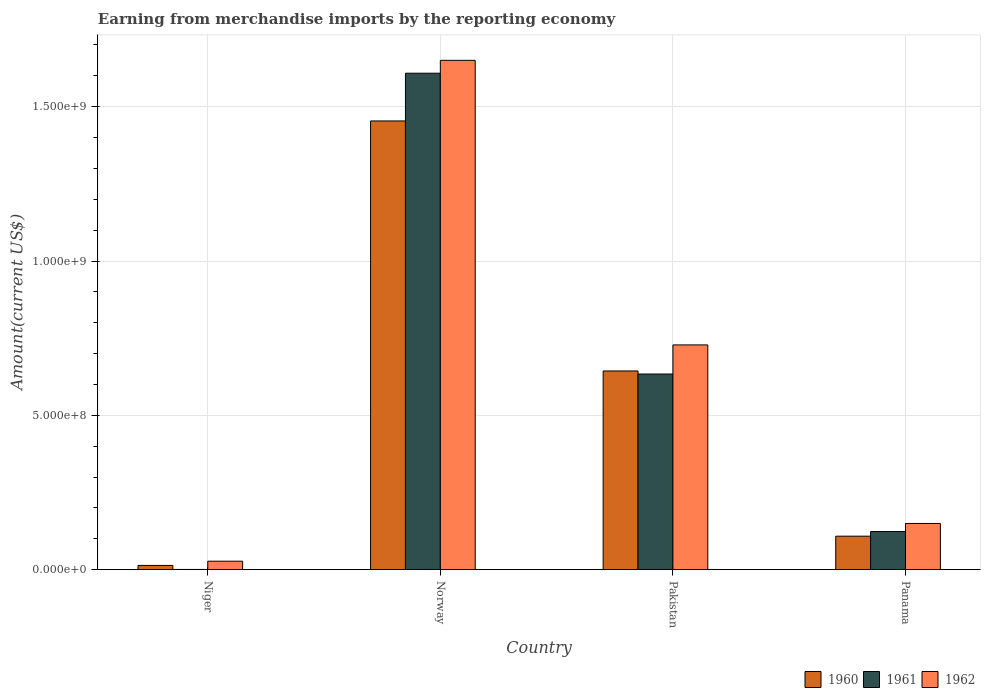How many different coloured bars are there?
Keep it short and to the point. 3. How many bars are there on the 4th tick from the left?
Give a very brief answer. 3. What is the label of the 4th group of bars from the left?
Your response must be concise. Panama. What is the amount earned from merchandise imports in 1962 in Norway?
Your answer should be compact. 1.65e+09. Across all countries, what is the maximum amount earned from merchandise imports in 1960?
Offer a terse response. 1.45e+09. Across all countries, what is the minimum amount earned from merchandise imports in 1960?
Provide a short and direct response. 1.36e+07. In which country was the amount earned from merchandise imports in 1961 maximum?
Your answer should be compact. Norway. In which country was the amount earned from merchandise imports in 1961 minimum?
Offer a very short reply. Niger. What is the total amount earned from merchandise imports in 1962 in the graph?
Your answer should be compact. 2.56e+09. What is the difference between the amount earned from merchandise imports in 1962 in Niger and that in Norway?
Offer a very short reply. -1.62e+09. What is the difference between the amount earned from merchandise imports in 1960 in Norway and the amount earned from merchandise imports in 1961 in Pakistan?
Offer a very short reply. 8.20e+08. What is the average amount earned from merchandise imports in 1961 per country?
Make the answer very short. 5.92e+08. What is the difference between the amount earned from merchandise imports of/in 1962 and amount earned from merchandise imports of/in 1960 in Pakistan?
Your answer should be very brief. 8.44e+07. What is the ratio of the amount earned from merchandise imports in 1961 in Niger to that in Pakistan?
Offer a terse response. 0. Is the amount earned from merchandise imports in 1961 in Norway less than that in Pakistan?
Provide a succinct answer. No. What is the difference between the highest and the second highest amount earned from merchandise imports in 1961?
Make the answer very short. 9.75e+08. What is the difference between the highest and the lowest amount earned from merchandise imports in 1961?
Your response must be concise. 1.61e+09. What does the 1st bar from the left in Norway represents?
Your answer should be compact. 1960. What does the 2nd bar from the right in Pakistan represents?
Provide a succinct answer. 1961. How many bars are there?
Keep it short and to the point. 12. Are all the bars in the graph horizontal?
Offer a terse response. No. How many countries are there in the graph?
Your response must be concise. 4. Are the values on the major ticks of Y-axis written in scientific E-notation?
Your answer should be compact. Yes. Does the graph contain grids?
Ensure brevity in your answer.  Yes. Where does the legend appear in the graph?
Offer a very short reply. Bottom right. How many legend labels are there?
Provide a short and direct response. 3. How are the legend labels stacked?
Your answer should be very brief. Horizontal. What is the title of the graph?
Give a very brief answer. Earning from merchandise imports by the reporting economy. Does "1982" appear as one of the legend labels in the graph?
Ensure brevity in your answer.  No. What is the label or title of the X-axis?
Keep it short and to the point. Country. What is the label or title of the Y-axis?
Make the answer very short. Amount(current US$). What is the Amount(current US$) in 1960 in Niger?
Keep it short and to the point. 1.36e+07. What is the Amount(current US$) of 1961 in Niger?
Give a very brief answer. 6.00e+05. What is the Amount(current US$) in 1962 in Niger?
Your answer should be compact. 2.73e+07. What is the Amount(current US$) in 1960 in Norway?
Keep it short and to the point. 1.45e+09. What is the Amount(current US$) in 1961 in Norway?
Make the answer very short. 1.61e+09. What is the Amount(current US$) in 1962 in Norway?
Give a very brief answer. 1.65e+09. What is the Amount(current US$) of 1960 in Pakistan?
Ensure brevity in your answer.  6.44e+08. What is the Amount(current US$) in 1961 in Pakistan?
Offer a terse response. 6.34e+08. What is the Amount(current US$) in 1962 in Pakistan?
Offer a terse response. 7.28e+08. What is the Amount(current US$) of 1960 in Panama?
Provide a short and direct response. 1.08e+08. What is the Amount(current US$) in 1961 in Panama?
Keep it short and to the point. 1.23e+08. What is the Amount(current US$) of 1962 in Panama?
Ensure brevity in your answer.  1.50e+08. Across all countries, what is the maximum Amount(current US$) in 1960?
Give a very brief answer. 1.45e+09. Across all countries, what is the maximum Amount(current US$) in 1961?
Offer a very short reply. 1.61e+09. Across all countries, what is the maximum Amount(current US$) in 1962?
Make the answer very short. 1.65e+09. Across all countries, what is the minimum Amount(current US$) of 1960?
Your response must be concise. 1.36e+07. Across all countries, what is the minimum Amount(current US$) of 1962?
Your answer should be very brief. 2.73e+07. What is the total Amount(current US$) of 1960 in the graph?
Your answer should be very brief. 2.22e+09. What is the total Amount(current US$) of 1961 in the graph?
Offer a very short reply. 2.37e+09. What is the total Amount(current US$) of 1962 in the graph?
Provide a short and direct response. 2.56e+09. What is the difference between the Amount(current US$) of 1960 in Niger and that in Norway?
Ensure brevity in your answer.  -1.44e+09. What is the difference between the Amount(current US$) of 1961 in Niger and that in Norway?
Offer a very short reply. -1.61e+09. What is the difference between the Amount(current US$) of 1962 in Niger and that in Norway?
Make the answer very short. -1.62e+09. What is the difference between the Amount(current US$) in 1960 in Niger and that in Pakistan?
Ensure brevity in your answer.  -6.30e+08. What is the difference between the Amount(current US$) in 1961 in Niger and that in Pakistan?
Your answer should be very brief. -6.33e+08. What is the difference between the Amount(current US$) of 1962 in Niger and that in Pakistan?
Give a very brief answer. -7.01e+08. What is the difference between the Amount(current US$) of 1960 in Niger and that in Panama?
Offer a terse response. -9.48e+07. What is the difference between the Amount(current US$) in 1961 in Niger and that in Panama?
Your response must be concise. -1.23e+08. What is the difference between the Amount(current US$) in 1962 in Niger and that in Panama?
Provide a short and direct response. -1.22e+08. What is the difference between the Amount(current US$) of 1960 in Norway and that in Pakistan?
Offer a very short reply. 8.10e+08. What is the difference between the Amount(current US$) of 1961 in Norway and that in Pakistan?
Make the answer very short. 9.75e+08. What is the difference between the Amount(current US$) of 1962 in Norway and that in Pakistan?
Keep it short and to the point. 9.22e+08. What is the difference between the Amount(current US$) of 1960 in Norway and that in Panama?
Your answer should be compact. 1.35e+09. What is the difference between the Amount(current US$) of 1961 in Norway and that in Panama?
Provide a short and direct response. 1.49e+09. What is the difference between the Amount(current US$) of 1962 in Norway and that in Panama?
Keep it short and to the point. 1.50e+09. What is the difference between the Amount(current US$) of 1960 in Pakistan and that in Panama?
Your response must be concise. 5.35e+08. What is the difference between the Amount(current US$) in 1961 in Pakistan and that in Panama?
Offer a very short reply. 5.10e+08. What is the difference between the Amount(current US$) in 1962 in Pakistan and that in Panama?
Provide a succinct answer. 5.78e+08. What is the difference between the Amount(current US$) in 1960 in Niger and the Amount(current US$) in 1961 in Norway?
Keep it short and to the point. -1.59e+09. What is the difference between the Amount(current US$) in 1960 in Niger and the Amount(current US$) in 1962 in Norway?
Offer a very short reply. -1.64e+09. What is the difference between the Amount(current US$) in 1961 in Niger and the Amount(current US$) in 1962 in Norway?
Offer a very short reply. -1.65e+09. What is the difference between the Amount(current US$) of 1960 in Niger and the Amount(current US$) of 1961 in Pakistan?
Your answer should be very brief. -6.20e+08. What is the difference between the Amount(current US$) of 1960 in Niger and the Amount(current US$) of 1962 in Pakistan?
Offer a terse response. -7.14e+08. What is the difference between the Amount(current US$) of 1961 in Niger and the Amount(current US$) of 1962 in Pakistan?
Keep it short and to the point. -7.28e+08. What is the difference between the Amount(current US$) of 1960 in Niger and the Amount(current US$) of 1961 in Panama?
Offer a very short reply. -1.10e+08. What is the difference between the Amount(current US$) in 1960 in Niger and the Amount(current US$) in 1962 in Panama?
Keep it short and to the point. -1.36e+08. What is the difference between the Amount(current US$) of 1961 in Niger and the Amount(current US$) of 1962 in Panama?
Your answer should be very brief. -1.49e+08. What is the difference between the Amount(current US$) of 1960 in Norway and the Amount(current US$) of 1961 in Pakistan?
Provide a succinct answer. 8.20e+08. What is the difference between the Amount(current US$) of 1960 in Norway and the Amount(current US$) of 1962 in Pakistan?
Provide a short and direct response. 7.26e+08. What is the difference between the Amount(current US$) of 1961 in Norway and the Amount(current US$) of 1962 in Pakistan?
Ensure brevity in your answer.  8.80e+08. What is the difference between the Amount(current US$) in 1960 in Norway and the Amount(current US$) in 1961 in Panama?
Your answer should be very brief. 1.33e+09. What is the difference between the Amount(current US$) of 1960 in Norway and the Amount(current US$) of 1962 in Panama?
Keep it short and to the point. 1.30e+09. What is the difference between the Amount(current US$) in 1961 in Norway and the Amount(current US$) in 1962 in Panama?
Provide a succinct answer. 1.46e+09. What is the difference between the Amount(current US$) of 1960 in Pakistan and the Amount(current US$) of 1961 in Panama?
Provide a short and direct response. 5.20e+08. What is the difference between the Amount(current US$) in 1960 in Pakistan and the Amount(current US$) in 1962 in Panama?
Make the answer very short. 4.94e+08. What is the difference between the Amount(current US$) of 1961 in Pakistan and the Amount(current US$) of 1962 in Panama?
Offer a terse response. 4.84e+08. What is the average Amount(current US$) of 1960 per country?
Provide a short and direct response. 5.55e+08. What is the average Amount(current US$) of 1961 per country?
Offer a very short reply. 5.92e+08. What is the average Amount(current US$) in 1962 per country?
Your response must be concise. 6.39e+08. What is the difference between the Amount(current US$) in 1960 and Amount(current US$) in 1961 in Niger?
Offer a terse response. 1.30e+07. What is the difference between the Amount(current US$) of 1960 and Amount(current US$) of 1962 in Niger?
Offer a terse response. -1.37e+07. What is the difference between the Amount(current US$) in 1961 and Amount(current US$) in 1962 in Niger?
Make the answer very short. -2.67e+07. What is the difference between the Amount(current US$) in 1960 and Amount(current US$) in 1961 in Norway?
Your answer should be very brief. -1.55e+08. What is the difference between the Amount(current US$) of 1960 and Amount(current US$) of 1962 in Norway?
Offer a terse response. -1.96e+08. What is the difference between the Amount(current US$) in 1961 and Amount(current US$) in 1962 in Norway?
Ensure brevity in your answer.  -4.17e+07. What is the difference between the Amount(current US$) of 1960 and Amount(current US$) of 1961 in Pakistan?
Your answer should be compact. 9.90e+06. What is the difference between the Amount(current US$) of 1960 and Amount(current US$) of 1962 in Pakistan?
Give a very brief answer. -8.44e+07. What is the difference between the Amount(current US$) in 1961 and Amount(current US$) in 1962 in Pakistan?
Keep it short and to the point. -9.43e+07. What is the difference between the Amount(current US$) of 1960 and Amount(current US$) of 1961 in Panama?
Offer a very short reply. -1.51e+07. What is the difference between the Amount(current US$) of 1960 and Amount(current US$) of 1962 in Panama?
Ensure brevity in your answer.  -4.12e+07. What is the difference between the Amount(current US$) of 1961 and Amount(current US$) of 1962 in Panama?
Ensure brevity in your answer.  -2.62e+07. What is the ratio of the Amount(current US$) in 1960 in Niger to that in Norway?
Your answer should be very brief. 0.01. What is the ratio of the Amount(current US$) of 1961 in Niger to that in Norway?
Give a very brief answer. 0. What is the ratio of the Amount(current US$) of 1962 in Niger to that in Norway?
Your response must be concise. 0.02. What is the ratio of the Amount(current US$) in 1960 in Niger to that in Pakistan?
Ensure brevity in your answer.  0.02. What is the ratio of the Amount(current US$) of 1961 in Niger to that in Pakistan?
Offer a very short reply. 0. What is the ratio of the Amount(current US$) in 1962 in Niger to that in Pakistan?
Offer a terse response. 0.04. What is the ratio of the Amount(current US$) of 1960 in Niger to that in Panama?
Offer a very short reply. 0.13. What is the ratio of the Amount(current US$) of 1961 in Niger to that in Panama?
Your response must be concise. 0. What is the ratio of the Amount(current US$) in 1962 in Niger to that in Panama?
Offer a very short reply. 0.18. What is the ratio of the Amount(current US$) in 1960 in Norway to that in Pakistan?
Your response must be concise. 2.26. What is the ratio of the Amount(current US$) of 1961 in Norway to that in Pakistan?
Offer a terse response. 2.54. What is the ratio of the Amount(current US$) in 1962 in Norway to that in Pakistan?
Make the answer very short. 2.27. What is the ratio of the Amount(current US$) of 1960 in Norway to that in Panama?
Offer a very short reply. 13.42. What is the ratio of the Amount(current US$) in 1961 in Norway to that in Panama?
Provide a short and direct response. 13.03. What is the ratio of the Amount(current US$) in 1962 in Norway to that in Panama?
Your answer should be very brief. 11.03. What is the ratio of the Amount(current US$) of 1960 in Pakistan to that in Panama?
Make the answer very short. 5.94. What is the ratio of the Amount(current US$) in 1961 in Pakistan to that in Panama?
Provide a succinct answer. 5.14. What is the ratio of the Amount(current US$) of 1962 in Pakistan to that in Panama?
Provide a succinct answer. 4.87. What is the difference between the highest and the second highest Amount(current US$) of 1960?
Offer a very short reply. 8.10e+08. What is the difference between the highest and the second highest Amount(current US$) of 1961?
Give a very brief answer. 9.75e+08. What is the difference between the highest and the second highest Amount(current US$) in 1962?
Provide a succinct answer. 9.22e+08. What is the difference between the highest and the lowest Amount(current US$) in 1960?
Ensure brevity in your answer.  1.44e+09. What is the difference between the highest and the lowest Amount(current US$) in 1961?
Offer a terse response. 1.61e+09. What is the difference between the highest and the lowest Amount(current US$) of 1962?
Provide a succinct answer. 1.62e+09. 